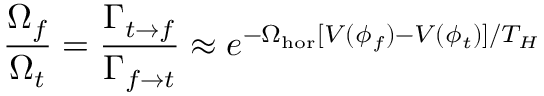<formula> <loc_0><loc_0><loc_500><loc_500>{ \frac { \Omega _ { f } } { \Omega _ { t } } } = { \frac { \Gamma _ { t \rightarrow f } } { \Gamma _ { f \rightarrow t } } } \approx e ^ { - \Omega _ { h o r } [ V ( \phi _ { f } ) - V ( \phi _ { t } ) ] / T _ { H } }</formula> 